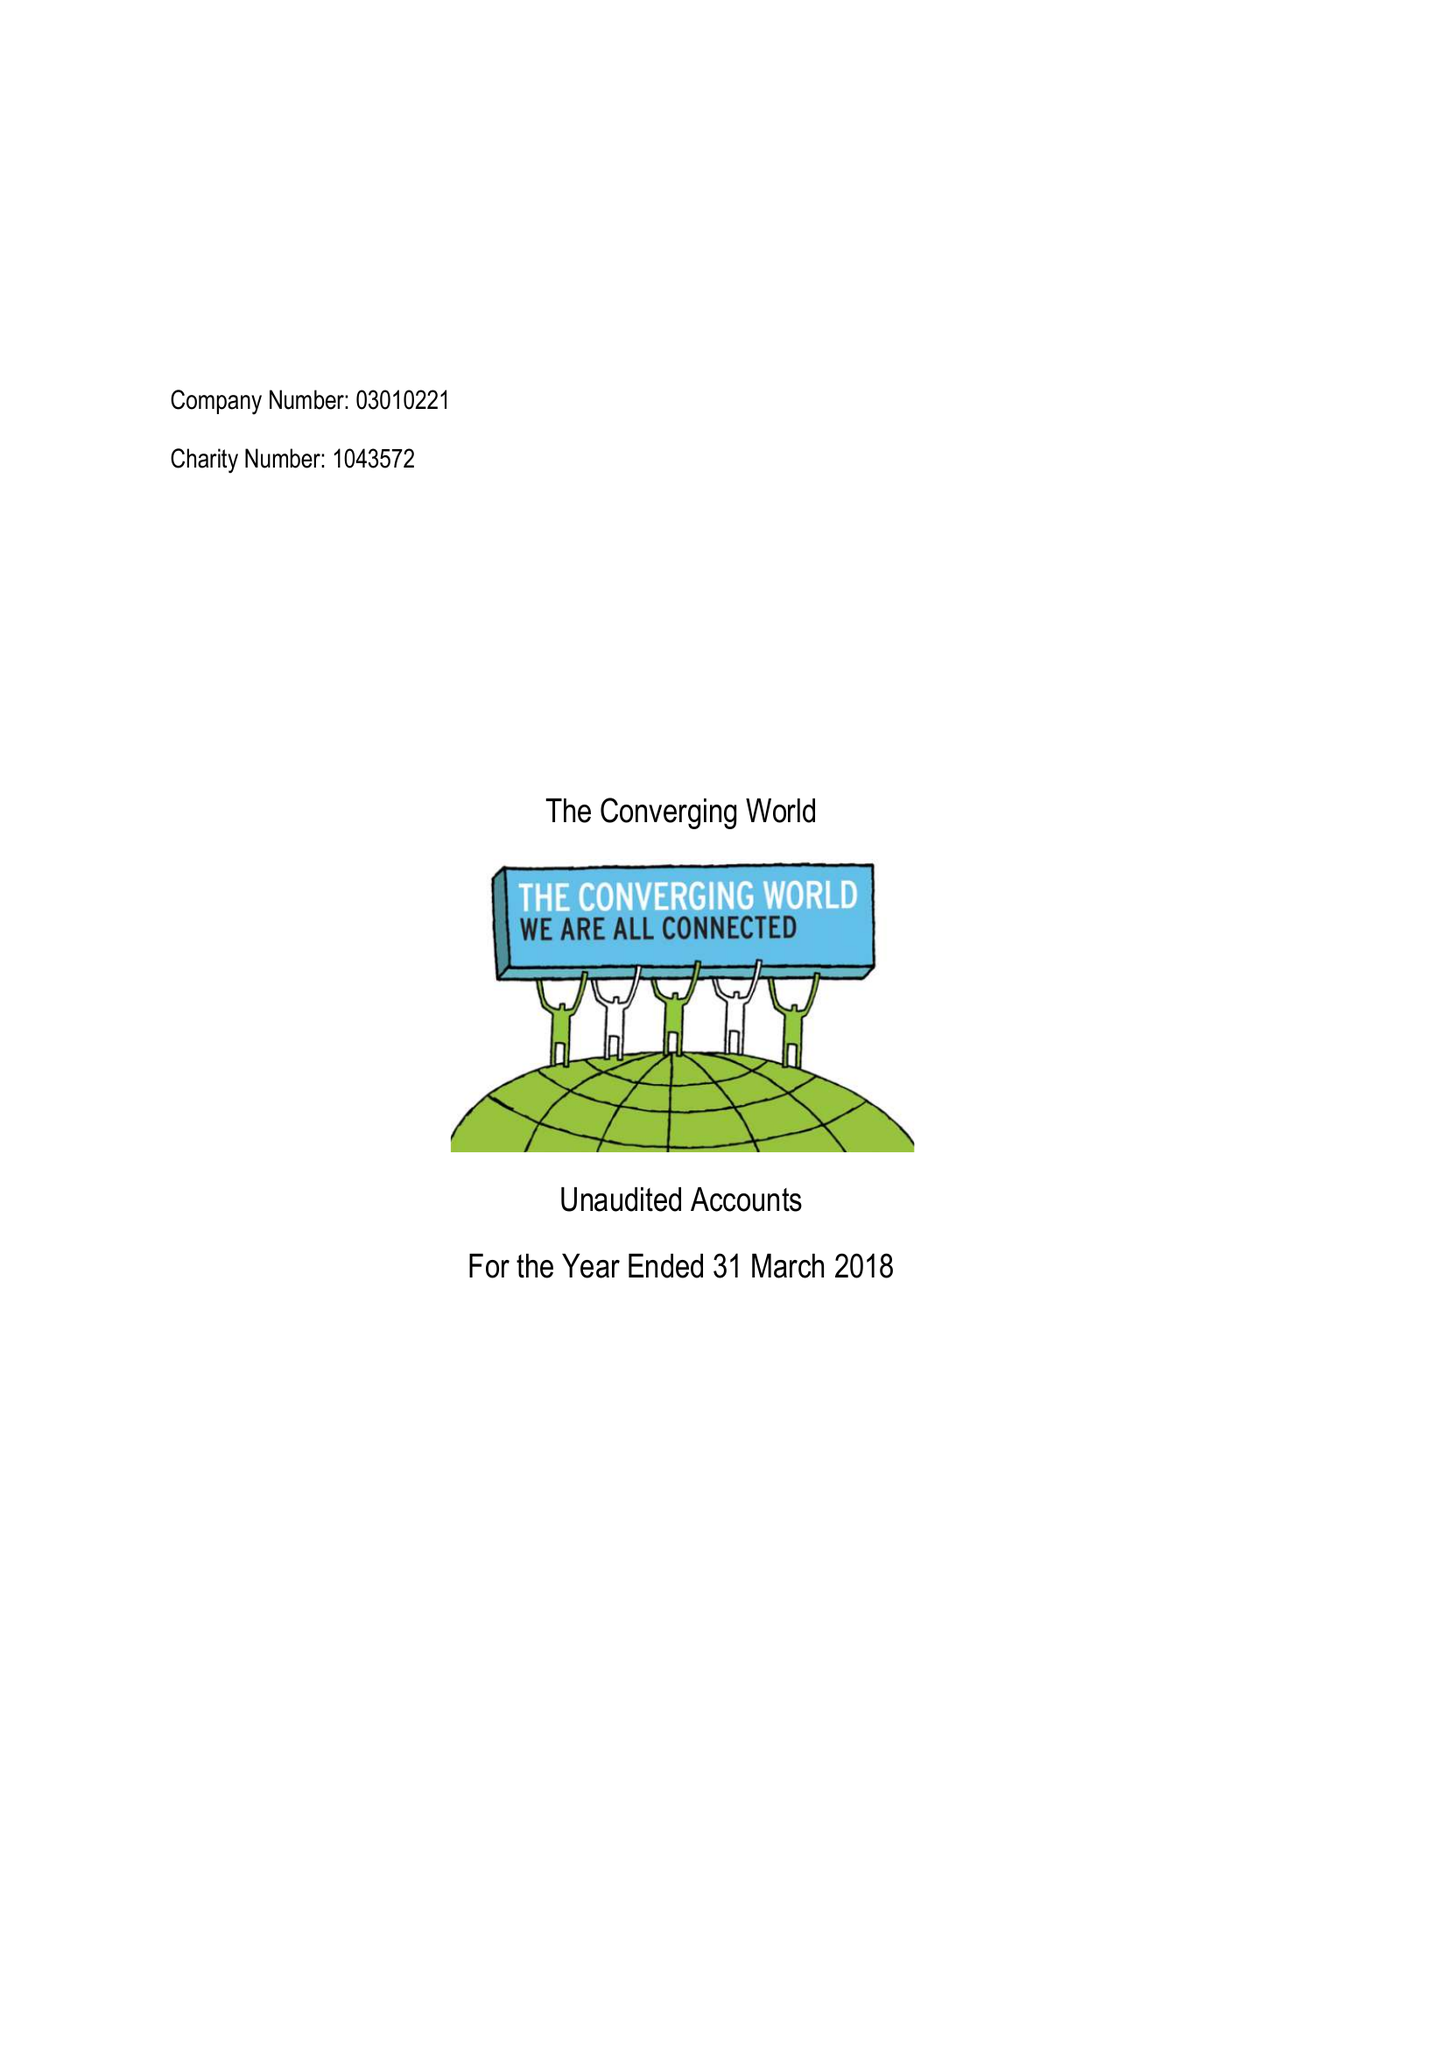What is the value for the address__postcode?
Answer the question using a single word or phrase. BS1 4HJ 